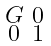<formula> <loc_0><loc_0><loc_500><loc_500>\begin{smallmatrix} G & 0 \\ 0 & 1 \end{smallmatrix}</formula> 